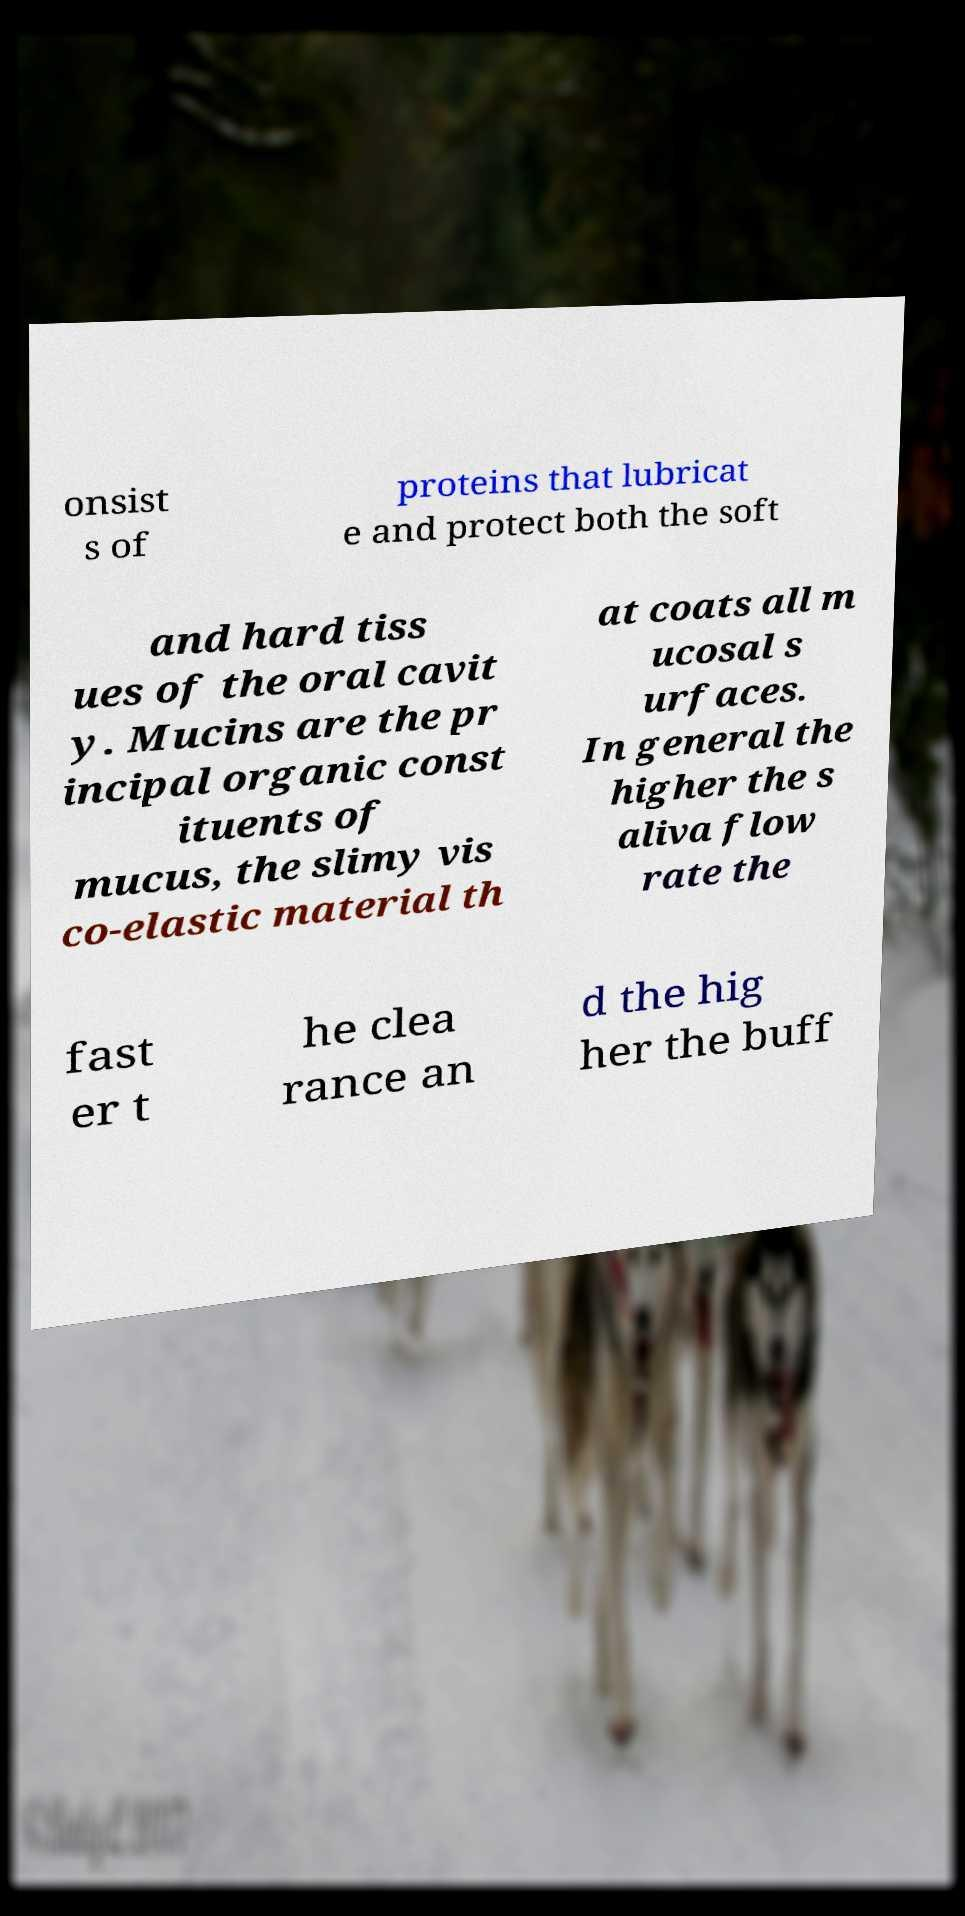I need the written content from this picture converted into text. Can you do that? onsist s of proteins that lubricat e and protect both the soft and hard tiss ues of the oral cavit y. Mucins are the pr incipal organic const ituents of mucus, the slimy vis co-elastic material th at coats all m ucosal s urfaces. In general the higher the s aliva flow rate the fast er t he clea rance an d the hig her the buff 